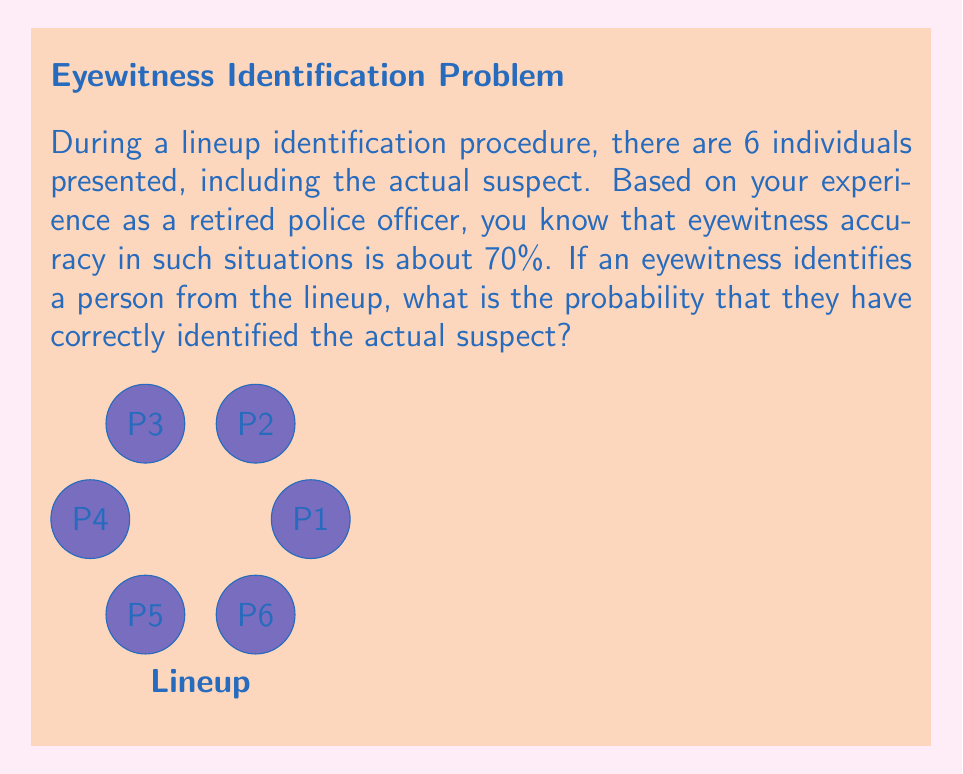Solve this math problem. Let's approach this step-by-step:

1) First, we need to define our events:
   A: The eyewitness identifies the correct suspect
   B: The eyewitness identifies someone from the lineup

2) We're looking for P(A|B), the probability that the identification is correct given that someone was identified.

3) We can use Bayes' Theorem:

   $$ P(A|B) = \frac{P(B|A) \cdot P(A)}{P(B)} $$

4) Now, let's break down each component:
   
   P(B|A) = 0.7 (given accuracy rate for correct identifications)
   P(A) = 1/6 (probability of selecting the correct suspect by chance)

5) To calculate P(B), we need to consider two scenarios:
   a) The witness correctly identifies the suspect: P(B|A) * P(A) = 0.7 * (1/6) = 7/60
   b) The witness incorrectly identifies an innocent person: 
      P(B|not A) * P(not A) = 0.3 * (5/6) = 1/4

   So, P(B) = 7/60 + 1/4 = 7/60 + 15/60 = 22/60

6) Now we can plug these values into Bayes' Theorem:

   $$ P(A|B) = \frac{0.7 \cdot (1/6)}{22/60} = \frac{0.7 \cdot (1/6)}{11/30} = \frac{21}{66} = \frac{7}{22} \approx 0.3182 $$
Answer: $\frac{7}{22}$ or approximately 31.82% 